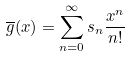Convert formula to latex. <formula><loc_0><loc_0><loc_500><loc_500>\overline { g } ( x ) = \sum _ { n = 0 } ^ { \infty } s _ { n } \frac { x ^ { n } } { n ! }</formula> 